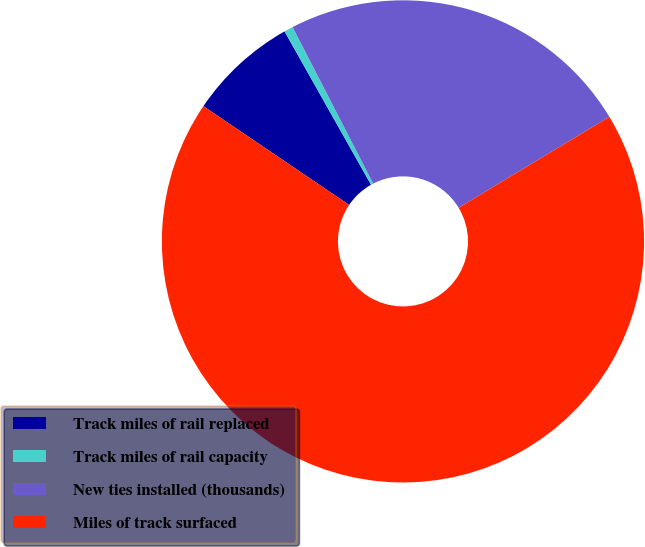Convert chart to OTSL. <chart><loc_0><loc_0><loc_500><loc_500><pie_chart><fcel>Track miles of rail replaced<fcel>Track miles of rail capacity<fcel>New ties installed (thousands)<fcel>Miles of track surfaced<nl><fcel>7.35%<fcel>0.6%<fcel>23.93%<fcel>68.12%<nl></chart> 